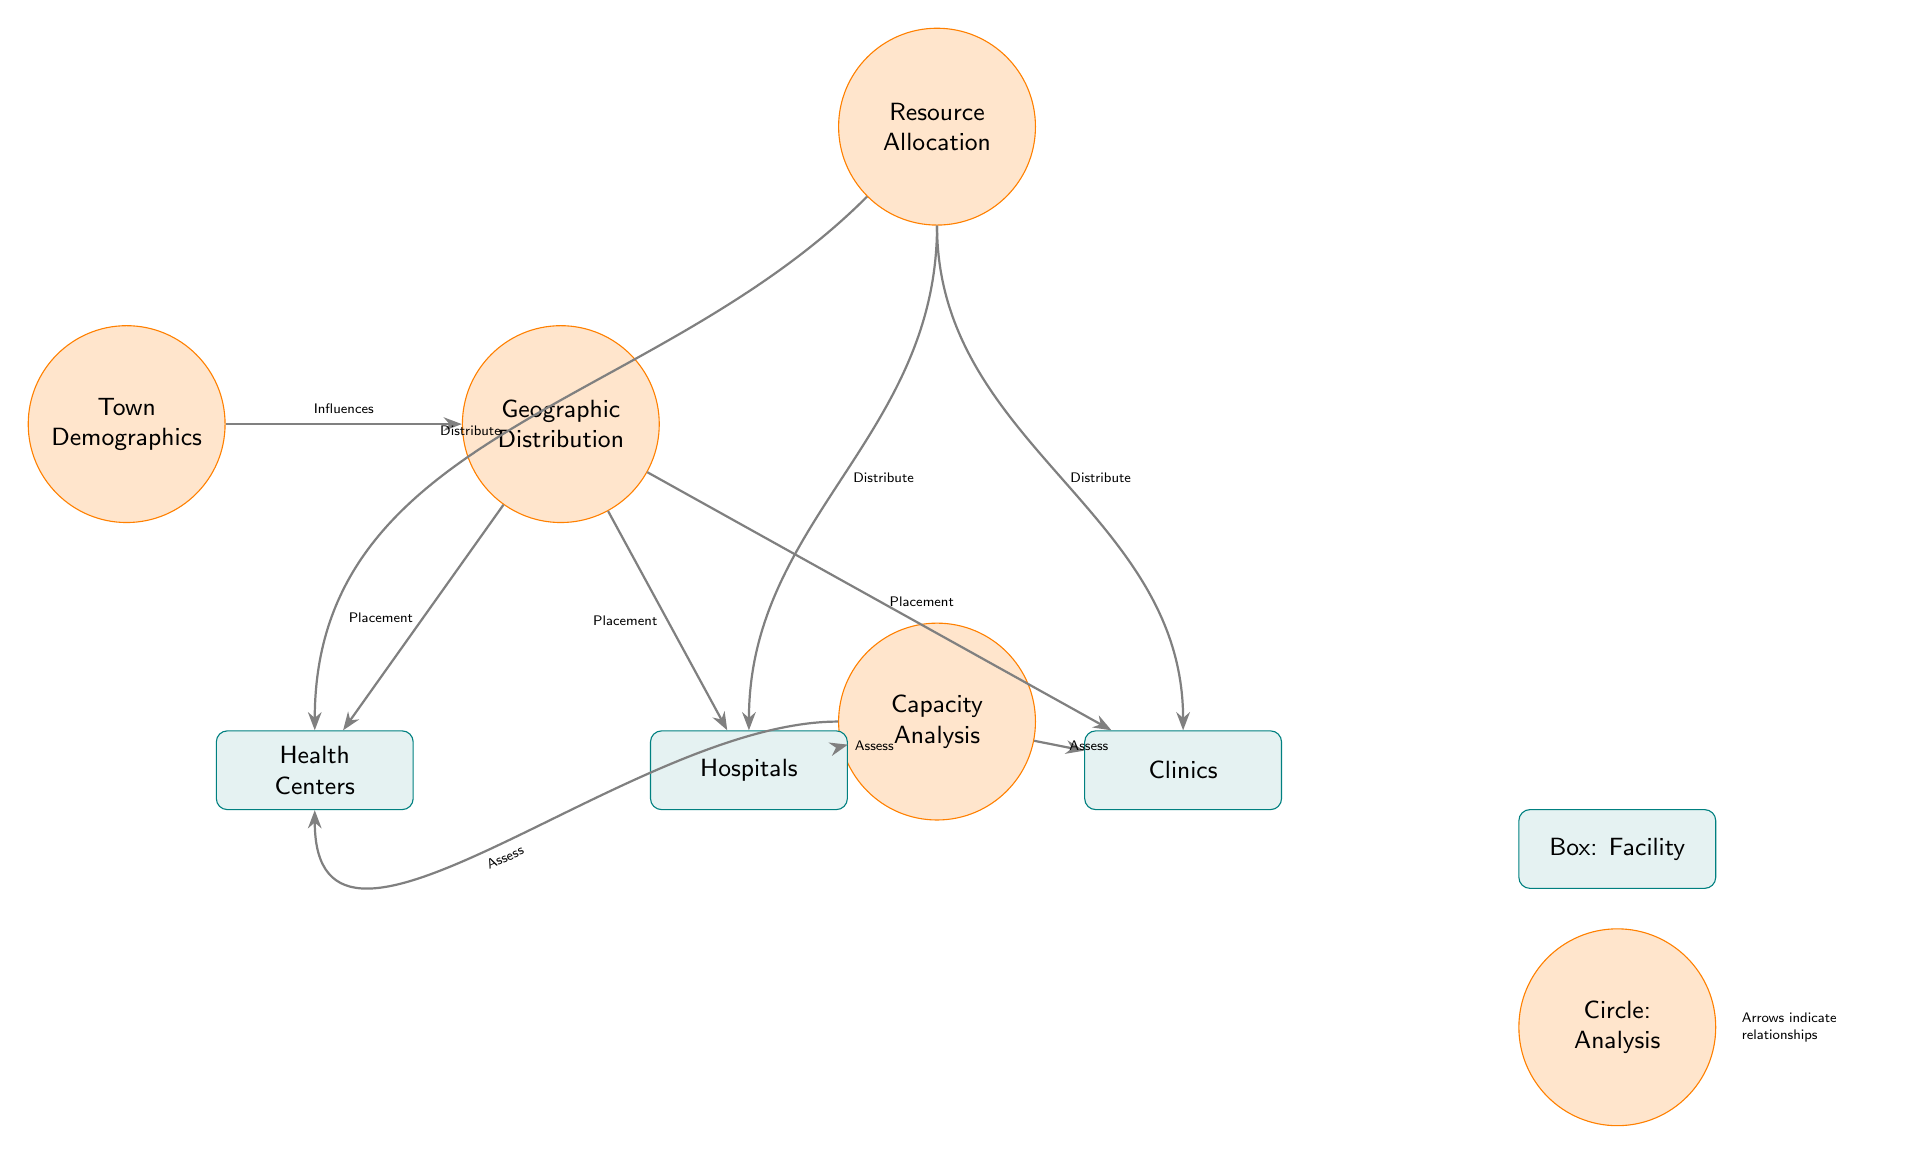What is the topmost node in the diagram? The topmost node in the diagram is "Town Demographics," which is positioned at the top above all other nodes.
Answer: Town Demographics How many types of healthcare facilities are represented in the diagram? There are three types of healthcare facilities represented: Hospitals, Clinics, and Health Centers, which are shown as box nodes in the diagram.
Answer: Three What is the relationship between "Geographic Distribution" and "Hospitals"? The relationship is established by an arrow indicating "Placement," which shows that the geographic distribution influences where hospitals are located.
Answer: Placement What type of node is "Capacity Analysis"? "Capacity Analysis" is a circle node, as it is drawn in a circular shape and colored in orange according to the diagram legend.
Answer: Circle Which node assesses the hospitals and clinics? "Capacity Analysis" assesses both hospitals and clinics as indicated by arrows directed from this node towards both facility types.
Answer: Capacity Analysis Describe the flow of resource allocation to health centers. The flow begins at "Resource Allocation," which distributes resources to health centers, as shown by an arrow that curves to indicate distribution towards the health center node.
Answer: Resource Allocation How many edges are coming out from the "Geographic Distribution" node? There are three edges coming out from the "Geographic Distribution" node, directed towards Hospitals, Clinics, and Health Centers respectively.
Answer: Three Which facility assesses health centers? Health Centers are assessed by "Capacity Analysis," indicated by a curved arrow leading to the Health Center node.
Answer: Capacity Analysis What does the legend explain about the circles in the diagram? The legend explains that the circles represent analysis, clarifying the meaning of the circular nodes within the diagram.
Answer: Analysis 